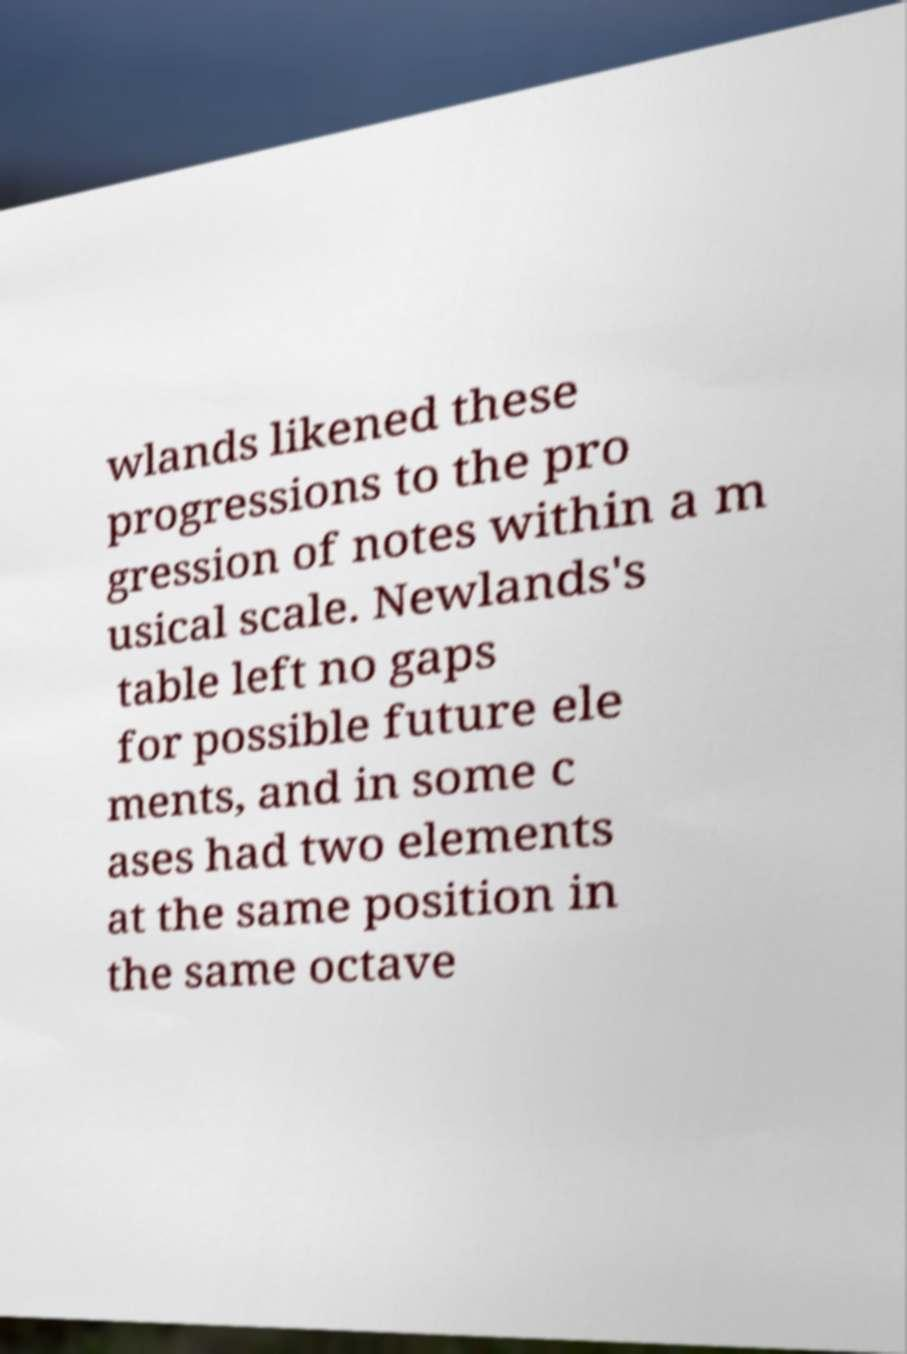There's text embedded in this image that I need extracted. Can you transcribe it verbatim? wlands likened these progressions to the pro gression of notes within a m usical scale. Newlands's table left no gaps for possible future ele ments, and in some c ases had two elements at the same position in the same octave 